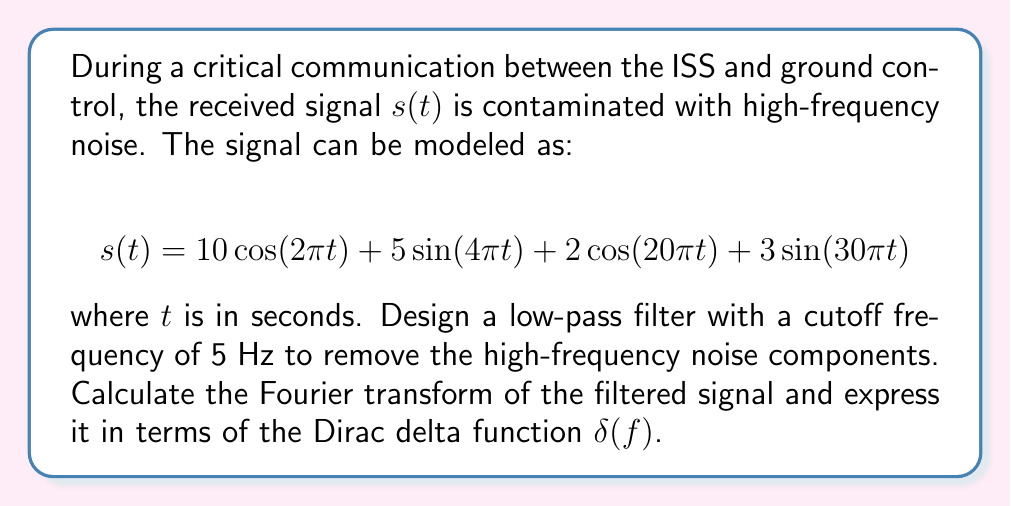Teach me how to tackle this problem. To solve this problem, we'll follow these steps:

1) First, let's identify the frequency components in the original signal:
   - $10\cos(2\pi t)$ has a frequency of 1 Hz
   - $5\sin(4\pi t)$ has a frequency of 2 Hz
   - $2\cos(20\pi t)$ has a frequency of 10 Hz
   - $3\sin(30\pi t)$ has a frequency of 15 Hz

2) The low-pass filter with a cutoff frequency of 5 Hz will remove the components with frequencies higher than 5 Hz. This means the last two terms will be filtered out.

3) The filtered signal $s_f(t)$ will be:

   $$s_f(t) = 10\cos(2\pi t) + 5\sin(4\pi t)$$

4) Now, let's calculate the Fourier transform of $s_f(t)$. We'll use the following Fourier transform pairs:

   $$\mathcal{F}\{\cos(2\pi f_0 t)\} = \frac{1}{2}[\delta(f-f_0) + \delta(f+f_0)]$$
   $$\mathcal{F}\{\sin(2\pi f_0 t)\} = \frac{1}{2j}[\delta(f-f_0) - \delta(f+f_0)]$$

5) For the first term:
   
   $$\mathcal{F}\{10\cos(2\pi t)\} = 5[\delta(f-1) + \delta(f+1)]$$

6) For the second term:
   
   $$\mathcal{F}\{5\sin(4\pi t)\} = \frac{5}{2j}[\delta(f-2) - \delta(f+2)]$$

7) The Fourier transform of the filtered signal $S_f(f)$ is the sum of these two transforms:

   $$S_f(f) = 5[\delta(f-1) + \delta(f+1)] + \frac{5}{2j}[\delta(f-2) - \delta(f+2)]$$

This is the final expression for the Fourier transform of the filtered signal in terms of the Dirac delta function.
Answer: $$S_f(f) = 5[\delta(f-1) + \delta(f+1)] + \frac{5}{2j}[\delta(f-2) - \delta(f+2)]$$ 